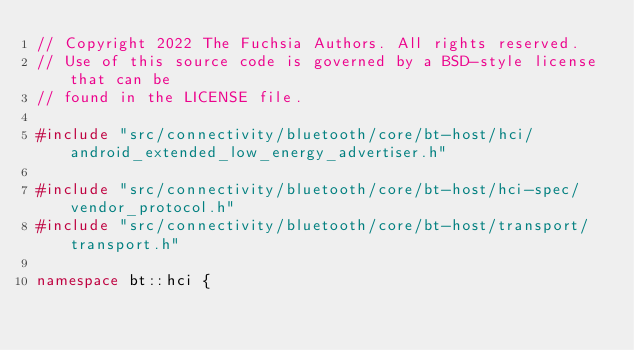Convert code to text. <code><loc_0><loc_0><loc_500><loc_500><_C++_>// Copyright 2022 The Fuchsia Authors. All rights reserved.
// Use of this source code is governed by a BSD-style license that can be
// found in the LICENSE file.

#include "src/connectivity/bluetooth/core/bt-host/hci/android_extended_low_energy_advertiser.h"

#include "src/connectivity/bluetooth/core/bt-host/hci-spec/vendor_protocol.h"
#include "src/connectivity/bluetooth/core/bt-host/transport/transport.h"

namespace bt::hci {
</code> 